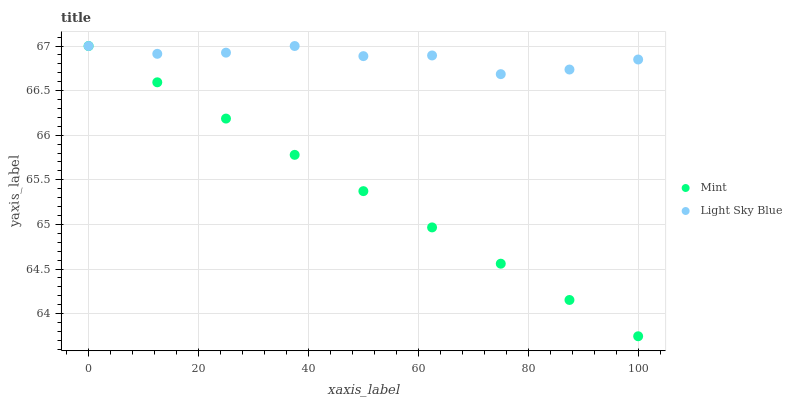Does Mint have the minimum area under the curve?
Answer yes or no. Yes. Does Light Sky Blue have the maximum area under the curve?
Answer yes or no. Yes. Does Mint have the maximum area under the curve?
Answer yes or no. No. Is Mint the smoothest?
Answer yes or no. Yes. Is Light Sky Blue the roughest?
Answer yes or no. Yes. Is Mint the roughest?
Answer yes or no. No. Does Mint have the lowest value?
Answer yes or no. Yes. Does Mint have the highest value?
Answer yes or no. Yes. Does Light Sky Blue intersect Mint?
Answer yes or no. Yes. Is Light Sky Blue less than Mint?
Answer yes or no. No. Is Light Sky Blue greater than Mint?
Answer yes or no. No. 